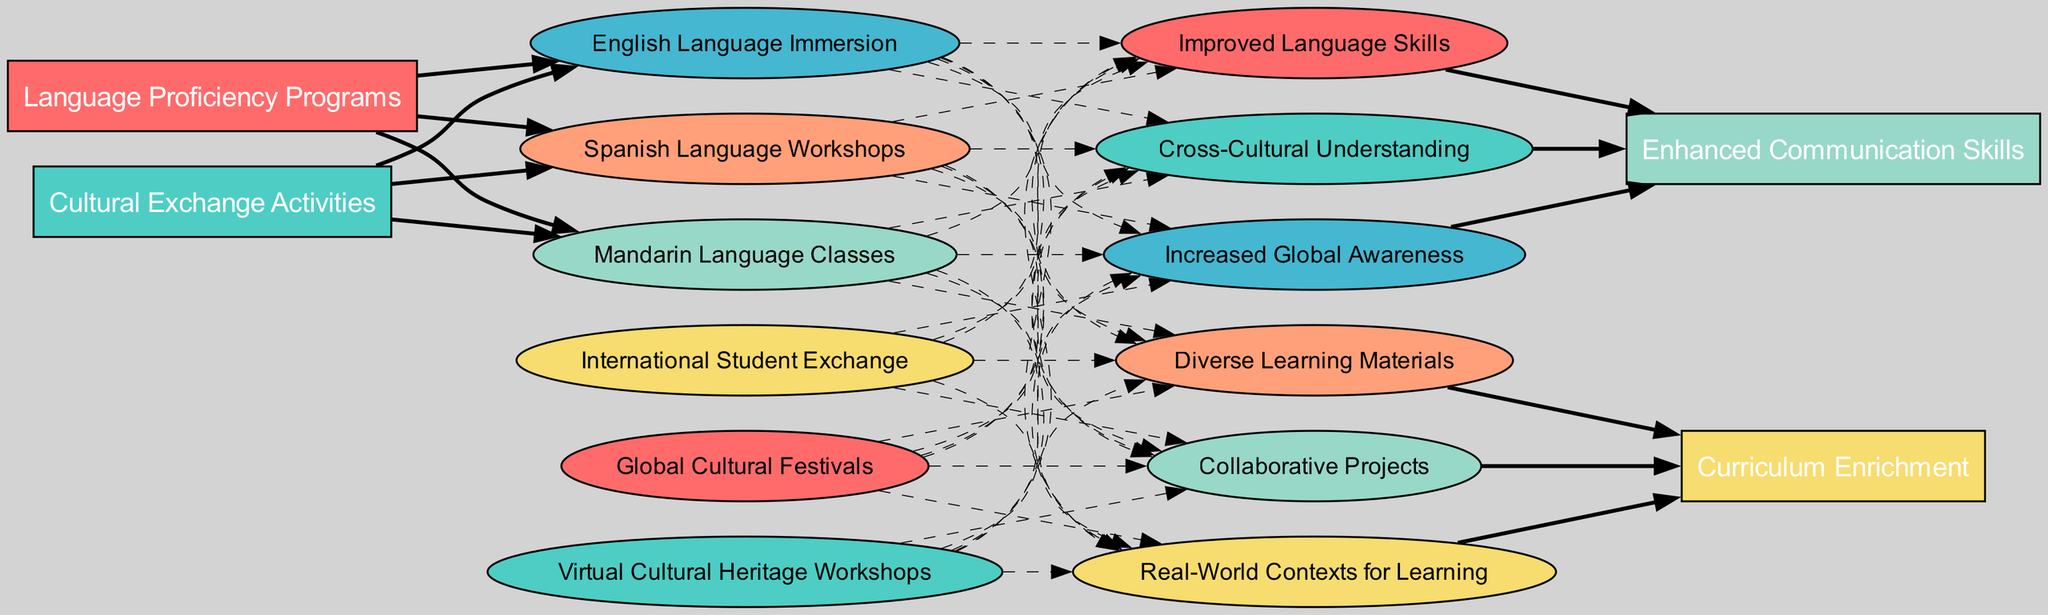What are the sources identified in the diagram? The sources listed in the diagram are shown at the left side of the Sankey Diagram. They include "Language Proficiency Programs" and "Cultural Exchange Activities."
Answer: Language Proficiency Programs, Cultural Exchange Activities How many contributions does the "Language Proficiency Programs" source have? The contributions for the "Language Proficiency Programs" are visible in the diagram and include three items: "English Language Immersion," "Spanish Language Workshops," and "Mandarin Language Classes." Therefore, there are three contributions.
Answer: 3 Which target is connected to "Virtual Cultural Heritage Workshops"? To find this, we look for the edge leading from "Virtual Cultural Heritage Workshops" towards the target nodes. It connects to "Curriculum Enrichment," as shown in the diagram.
Answer: Curriculum Enrichment What benefits are linked to the target "Enhanced Communication Skills"? This can be found by examining the edges connecting to the "Enhanced Communication Skills" target node. The benefits listed for this target are "Improved Language Skills," "Cross-Cultural Understanding," and "Increased Global Awareness."
Answer: Improved Language Skills, Cross-Cultural Understanding, Increased Global Awareness What is the relationship between "Spanish Language Workshops" and benefits? This question requires looking at both the contributions and benefits in the diagram. "Spanish Language Workshops" has edges leading to multiple benefits. The respective benefits include "Real-World Contexts for Learning," "Diverse Learning Materials," and "Collaborative Projects," through the pathways defined by edges from contributions to benefits.
Answer: Real-World Contexts for Learning, Diverse Learning Materials, Collaborative Projects How many edges are present in total in the diagram? We need to count all the edges that connect sources to contributions, contributions to benefits, and benefits to targets. The summary shows there are 6 edges from sources to contributions, and 6 edges from benefits to targets, plus various dashed edges leading from contributions to benefits. In total, summing these gives 14 edges in the diagram.
Answer: 14 Which language under "Language Proficiency Programs" has the most connections to benefits? By examining the contributions under "Language Proficiency Programs," the connections to benefits show that "English Language Immersion" connects to multiple benefits, ultimately making it the language with the most connections, as it leads to benefits affecting both targets.
Answer: English Language Immersion How many total contributions are represented in the diagram? By aggregating contributions from both sources, we find there are three from "Language Proficiency Programs" and three from "Cultural Exchange Activities," totaling six contributions overall.
Answer: 6 What type of educational activity does "Global Cultural Festivals" represent? This can be determined by identifying the source category it is connected to, which in the diagram is categorized under "Cultural Exchange Activities." Therefore, it represents a cultural exchange activity.
Answer: Cultural exchange activity 